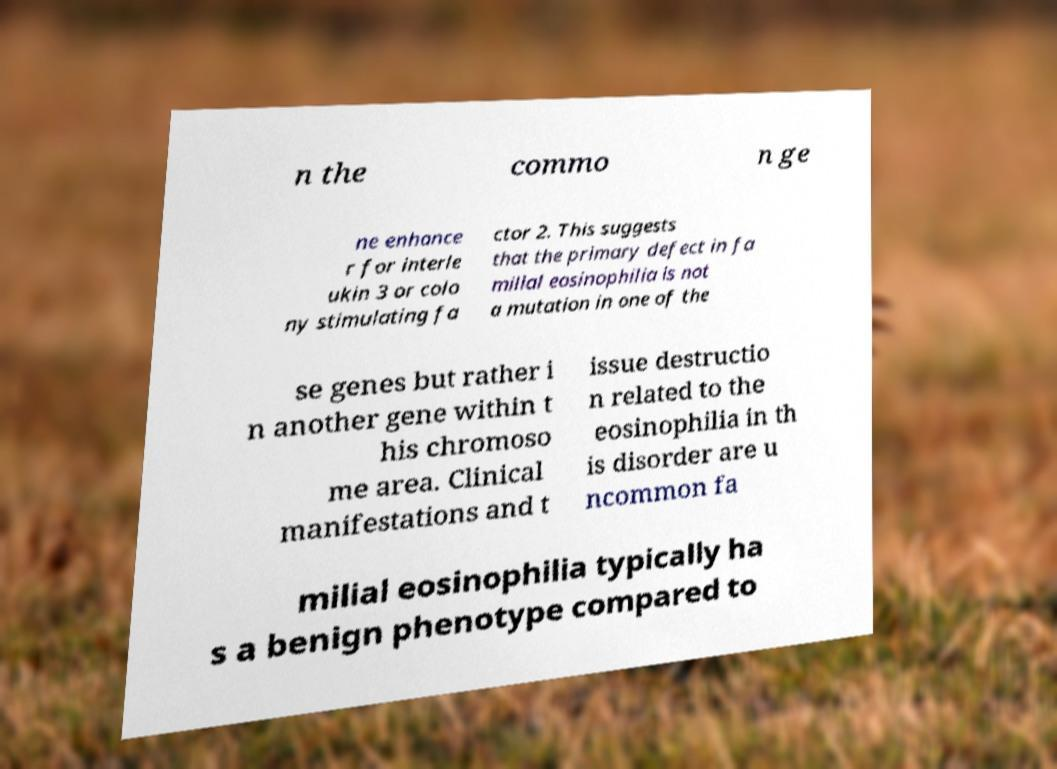Can you read and provide the text displayed in the image?This photo seems to have some interesting text. Can you extract and type it out for me? n the commo n ge ne enhance r for interle ukin 3 or colo ny stimulating fa ctor 2. This suggests that the primary defect in fa milial eosinophilia is not a mutation in one of the se genes but rather i n another gene within t his chromoso me area. Clinical manifestations and t issue destructio n related to the eosinophilia in th is disorder are u ncommon fa milial eosinophilia typically ha s a benign phenotype compared to 